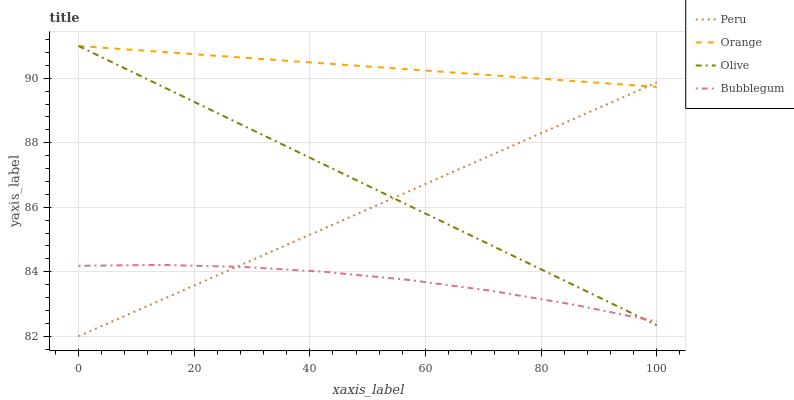Does Bubblegum have the minimum area under the curve?
Answer yes or no. Yes. Does Orange have the maximum area under the curve?
Answer yes or no. Yes. Does Olive have the minimum area under the curve?
Answer yes or no. No. Does Olive have the maximum area under the curve?
Answer yes or no. No. Is Orange the smoothest?
Answer yes or no. Yes. Is Bubblegum the roughest?
Answer yes or no. Yes. Is Olive the smoothest?
Answer yes or no. No. Is Olive the roughest?
Answer yes or no. No. Does Peru have the lowest value?
Answer yes or no. Yes. Does Olive have the lowest value?
Answer yes or no. No. Does Olive have the highest value?
Answer yes or no. Yes. Does Bubblegum have the highest value?
Answer yes or no. No. Is Bubblegum less than Orange?
Answer yes or no. Yes. Is Orange greater than Bubblegum?
Answer yes or no. Yes. Does Peru intersect Olive?
Answer yes or no. Yes. Is Peru less than Olive?
Answer yes or no. No. Is Peru greater than Olive?
Answer yes or no. No. Does Bubblegum intersect Orange?
Answer yes or no. No. 